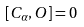<formula> <loc_0><loc_0><loc_500><loc_500>[ C _ { \alpha } , O ] = 0</formula> 